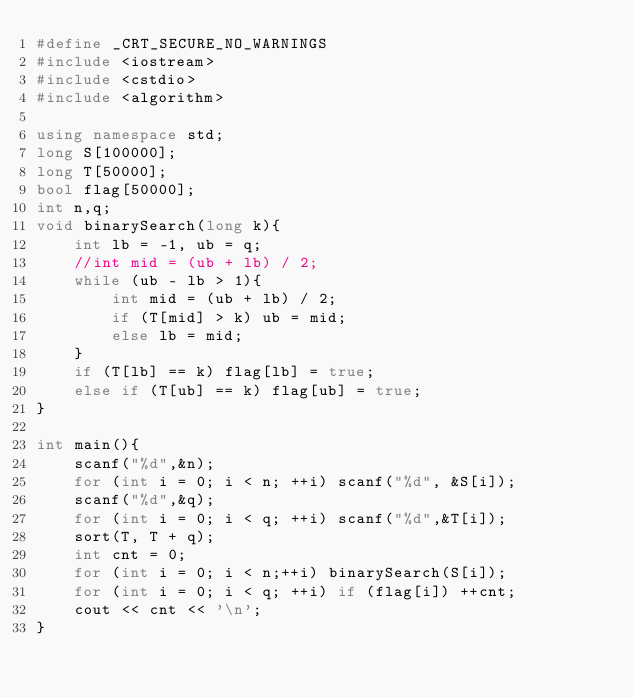Convert code to text. <code><loc_0><loc_0><loc_500><loc_500><_C++_>#define _CRT_SECURE_NO_WARNINGS
#include <iostream>
#include <cstdio>
#include <algorithm>

using namespace std;
long S[100000];
long T[50000];
bool flag[50000];
int n,q;
void binarySearch(long k){
	int lb = -1, ub = q;
	//int mid = (ub + lb) / 2;
	while (ub - lb > 1){
		int mid = (ub + lb) / 2;
		if (T[mid] > k) ub = mid;
		else lb = mid;
	}
	if (T[lb] == k) flag[lb] = true;
	else if (T[ub] == k) flag[ub] = true;
}

int main(){
	scanf("%d",&n);
	for (int i = 0; i < n; ++i) scanf("%d", &S[i]);
	scanf("%d",&q);
	for (int i = 0; i < q; ++i) scanf("%d",&T[i]);
	sort(T, T + q);
	int cnt = 0;
	for (int i = 0; i < n;++i) binarySearch(S[i]);
	for (int i = 0; i < q; ++i) if (flag[i]) ++cnt;
	cout << cnt << '\n';
}</code> 